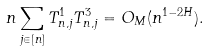Convert formula to latex. <formula><loc_0><loc_0><loc_500><loc_500>n \sum _ { j \in [ n ] } T ^ { 1 } _ { n , j } T ^ { 3 } _ { n , j } = O _ { M } ( n ^ { 1 - 2 H } ) .</formula> 